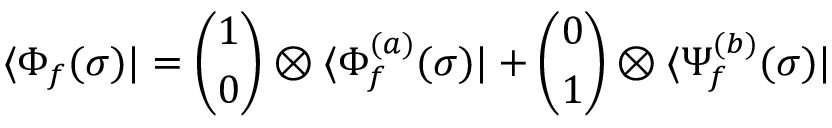<formula> <loc_0><loc_0><loc_500><loc_500>\langle \Phi _ { f } ( \sigma ) | = \binom { 1 } { 0 } \otimes \langle \Phi _ { f } ^ { ( a ) } ( \sigma ) | + \binom { 0 } { 1 } \otimes \langle \Psi _ { f } ^ { ( b ) } ( \sigma ) |</formula> 